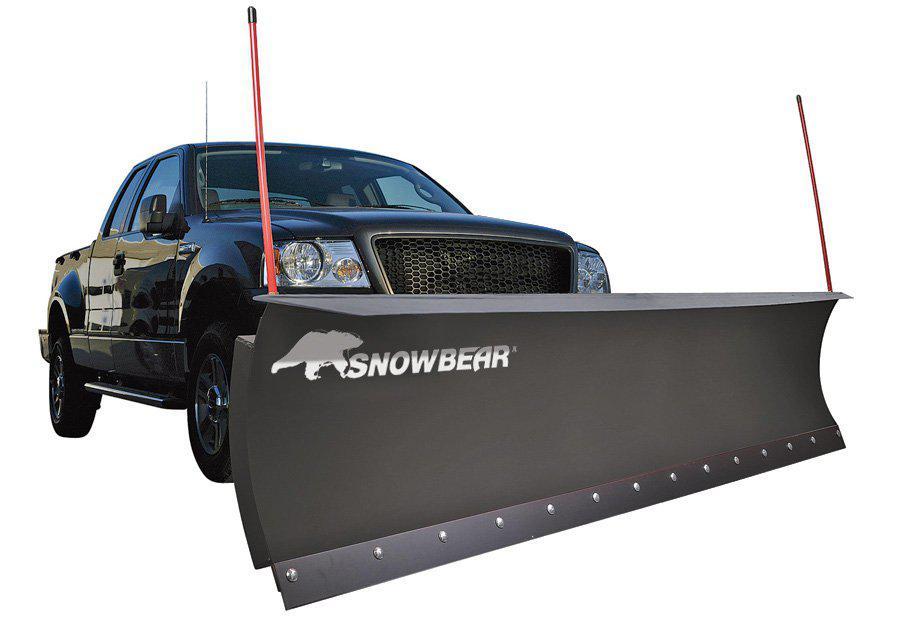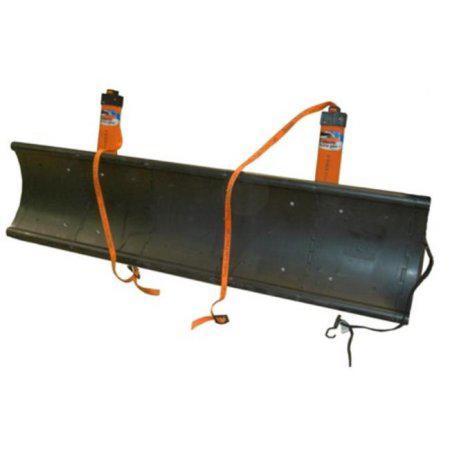The first image is the image on the left, the second image is the image on the right. Analyze the images presented: Is the assertion "A white plow is attached to a truck in one of the images." valid? Answer yes or no. No. The first image is the image on the left, the second image is the image on the right. For the images displayed, is the sentence "One image shows a pickup truck angled facing to the right with a plow attachment in front." factually correct? Answer yes or no. Yes. 